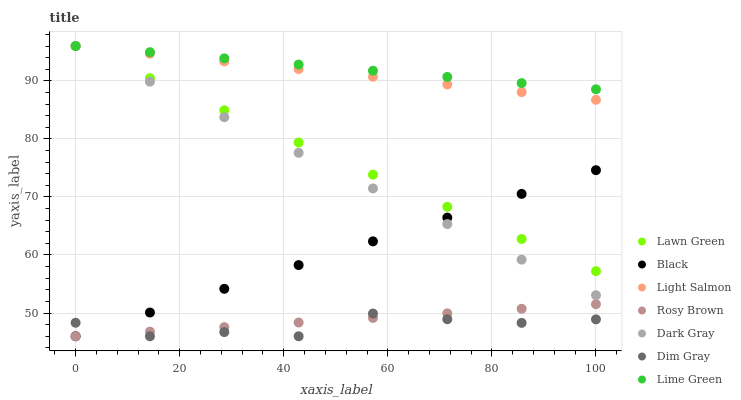Does Dim Gray have the minimum area under the curve?
Answer yes or no. Yes. Does Lime Green have the maximum area under the curve?
Answer yes or no. Yes. Does Light Salmon have the minimum area under the curve?
Answer yes or no. No. Does Light Salmon have the maximum area under the curve?
Answer yes or no. No. Is Light Salmon the smoothest?
Answer yes or no. Yes. Is Dim Gray the roughest?
Answer yes or no. Yes. Is Dim Gray the smoothest?
Answer yes or no. No. Is Light Salmon the roughest?
Answer yes or no. No. Does Dim Gray have the lowest value?
Answer yes or no. Yes. Does Light Salmon have the lowest value?
Answer yes or no. No. Does Lime Green have the highest value?
Answer yes or no. Yes. Does Dim Gray have the highest value?
Answer yes or no. No. Is Black less than Lime Green?
Answer yes or no. Yes. Is Lime Green greater than Rosy Brown?
Answer yes or no. Yes. Does Light Salmon intersect Dark Gray?
Answer yes or no. Yes. Is Light Salmon less than Dark Gray?
Answer yes or no. No. Is Light Salmon greater than Dark Gray?
Answer yes or no. No. Does Black intersect Lime Green?
Answer yes or no. No. 